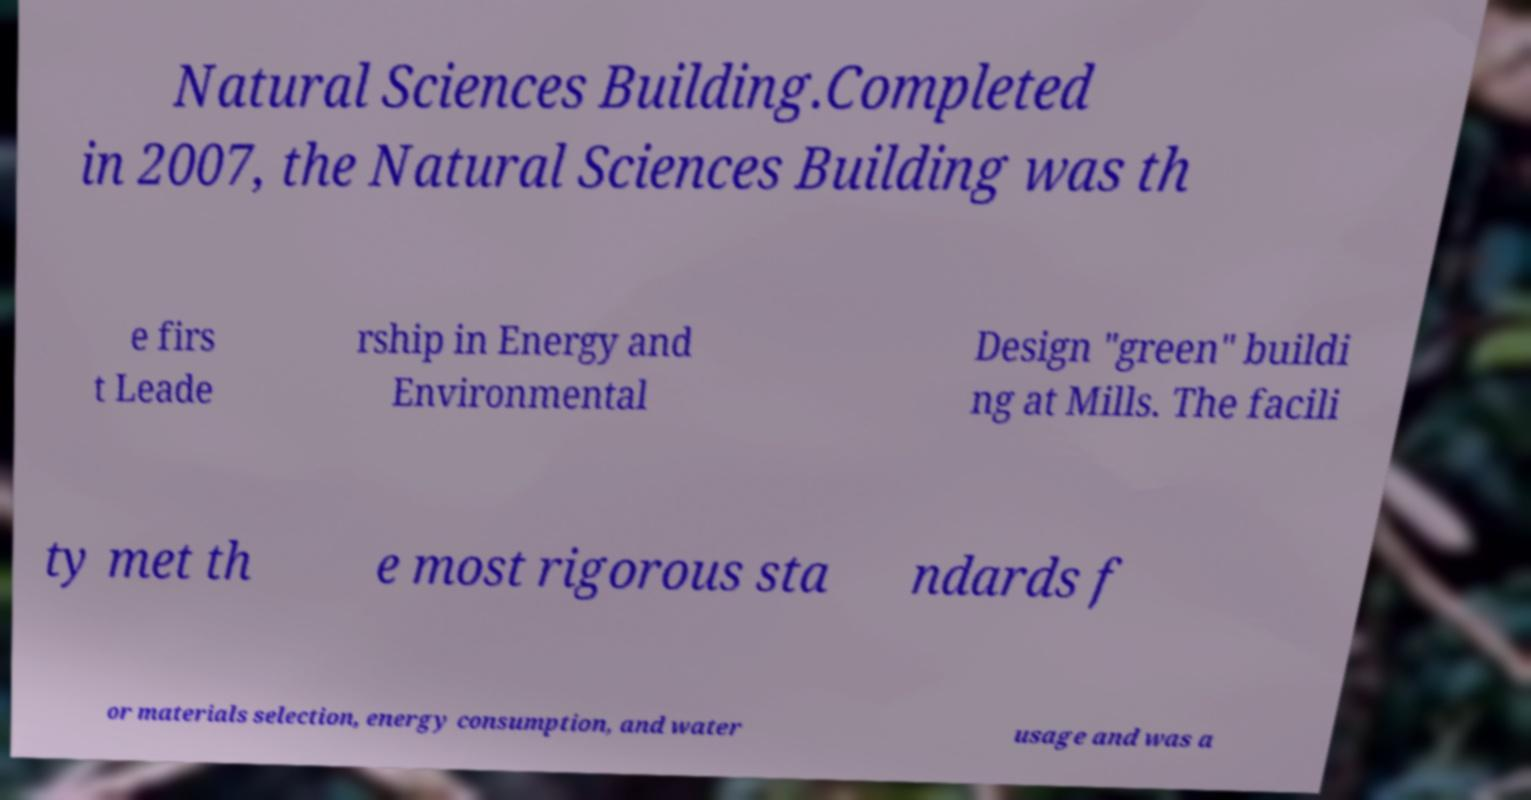Please read and relay the text visible in this image. What does it say? Natural Sciences Building.Completed in 2007, the Natural Sciences Building was th e firs t Leade rship in Energy and Environmental Design "green" buildi ng at Mills. The facili ty met th e most rigorous sta ndards f or materials selection, energy consumption, and water usage and was a 